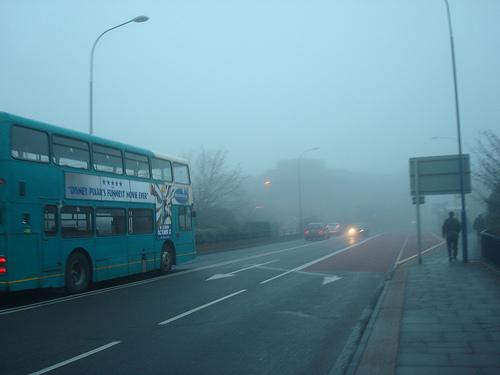Mention the primary building in the scene and its colors. The main building is a blue and white building located on the corner. Analyze the general sentiment perceived from the image. The sentiment perceived from the image is positive, with people enjoying an outdoor event. What type of vehicle is predominantly featured in the image? A blue double-decker bus is featured in the image. In which quadrant of the picture is the blue double-decker bus situated? The blue double-decker bus is situated in the top left quadrant of the image. Rate the image quality on a scale of 1 to 5, with 5 being the highest quality. Based on the metadata provided, the image quality is moderate, rating between 3 and 4. Enumerate the color composition of the primary building within the scene. The primary building in the scene is composed of blue and white colors. Estimate the size of the smallest set of goggles in the image. The smallest goggles have a width of 4 and a height of 4. Provide a count of the white goggles found in the photo. There are 10 sets of white goggles in the image. Identify the object sitting on the head of various men in the image. White goggles are sitting on top of multiple men's heads. 